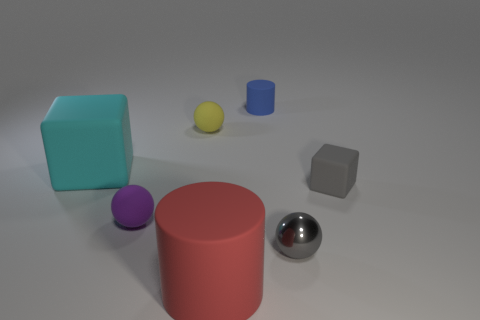Besides the matte spheres, what other shapes are present in the image, and what materials do they appear to be made from? The image features a variety of geometric shapes, including a turquoise cube and a coral cylinder that appear to have a matte finish, while the silver sphere and a gray hexahedron boast a reflective, metallic sheen. 